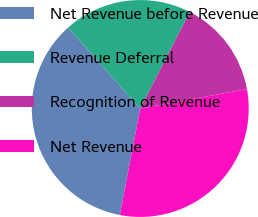Convert chart to OTSL. <chart><loc_0><loc_0><loc_500><loc_500><pie_chart><fcel>Net Revenue before Revenue<fcel>Revenue Deferral<fcel>Recognition of Revenue<fcel>Net Revenue<nl><fcel>35.4%<fcel>19.13%<fcel>14.6%<fcel>30.87%<nl></chart> 